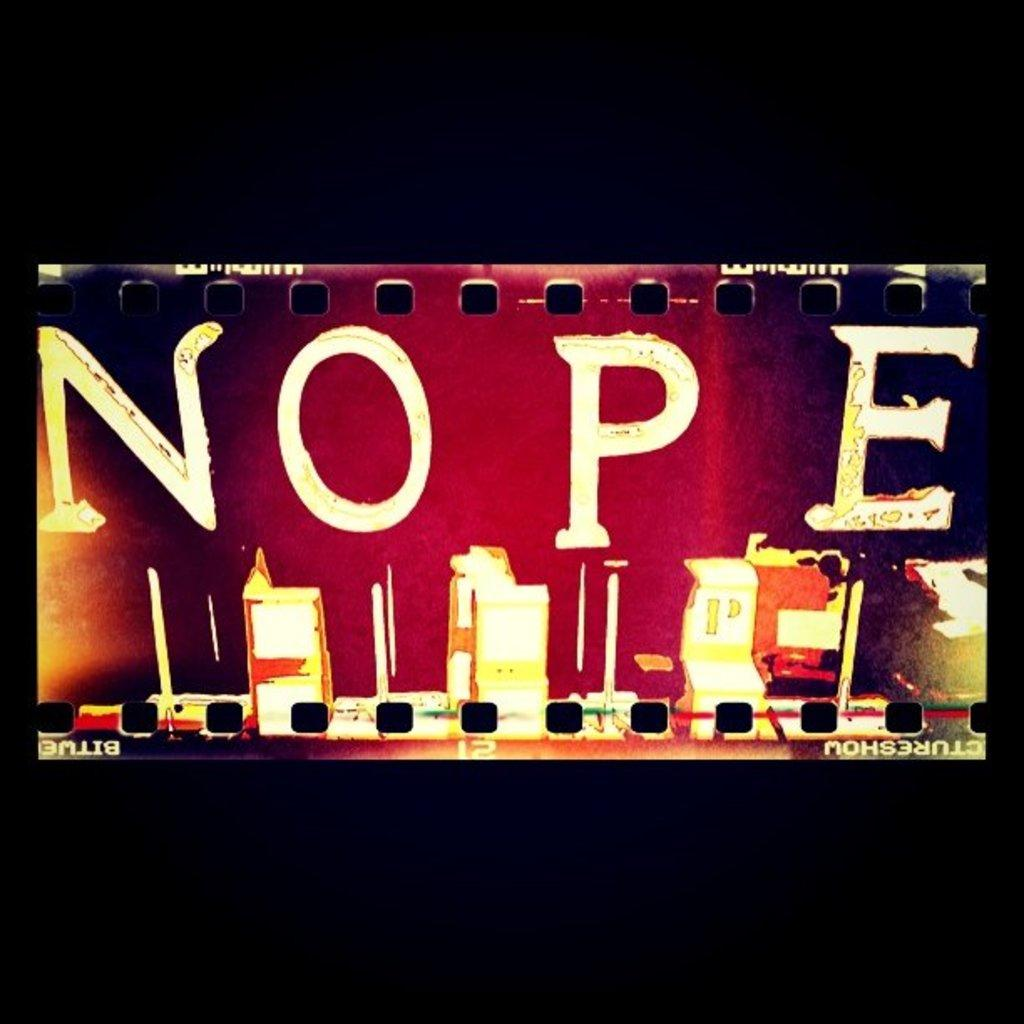<image>
Create a compact narrative representing the image presented. an image of some buildings with the word nope above it 